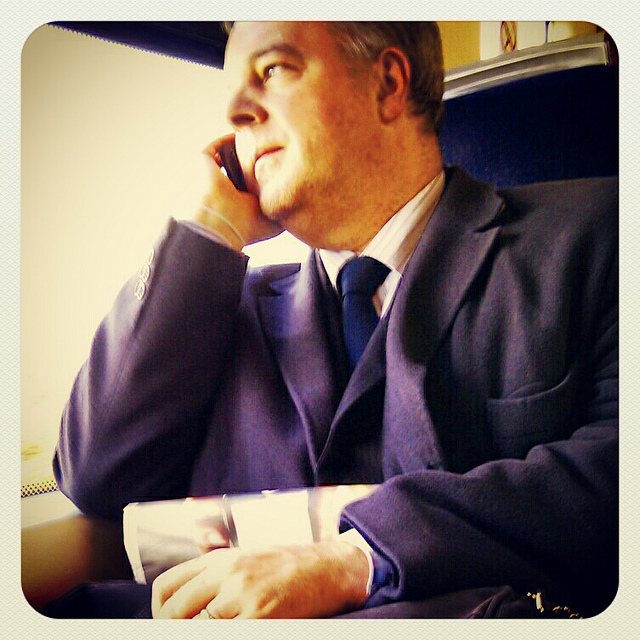Can you describe the person's attire? The individual in the photograph is wearing a classic dark blue suit with a white shirt. It's a business-professional look, which suggests that he might be on the way to a formal event or returning from a corporate environment. 